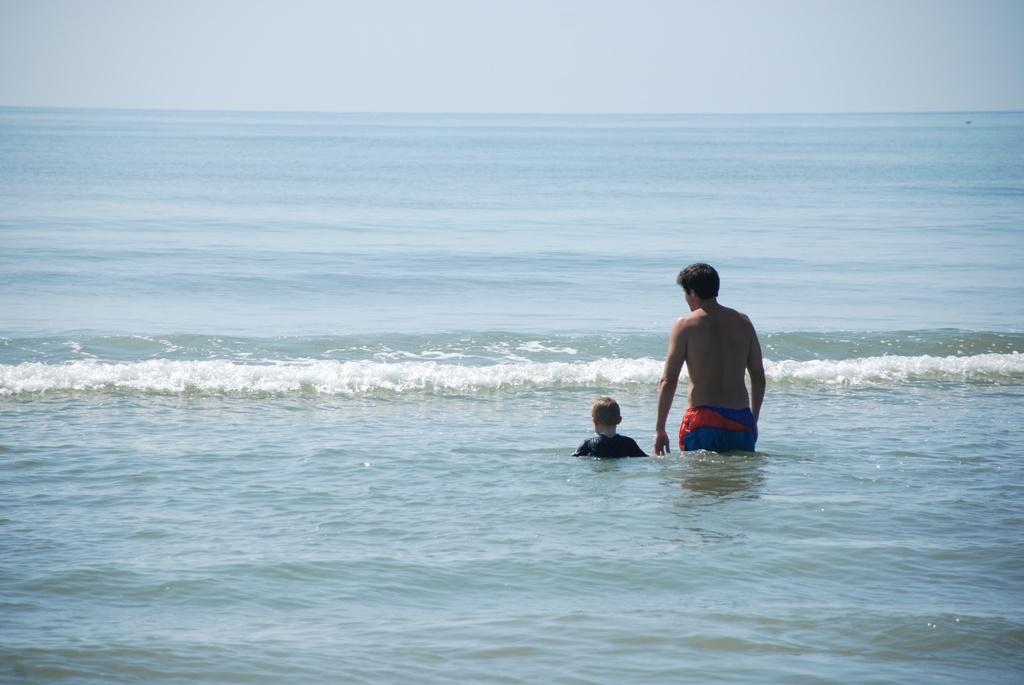What type of location is depicted at the bottom of the image? There is a beach at the bottom of the image. Are there any people present on the beach? Yes, there is a man and a boy on the beach. What can be seen in the sky at the top of the image? The sky is visible at the top of the image. What type of calculator is being advertised on the beach in the image? There is no calculator or advertisement present in the image; it features a beach with a man and a boy. 